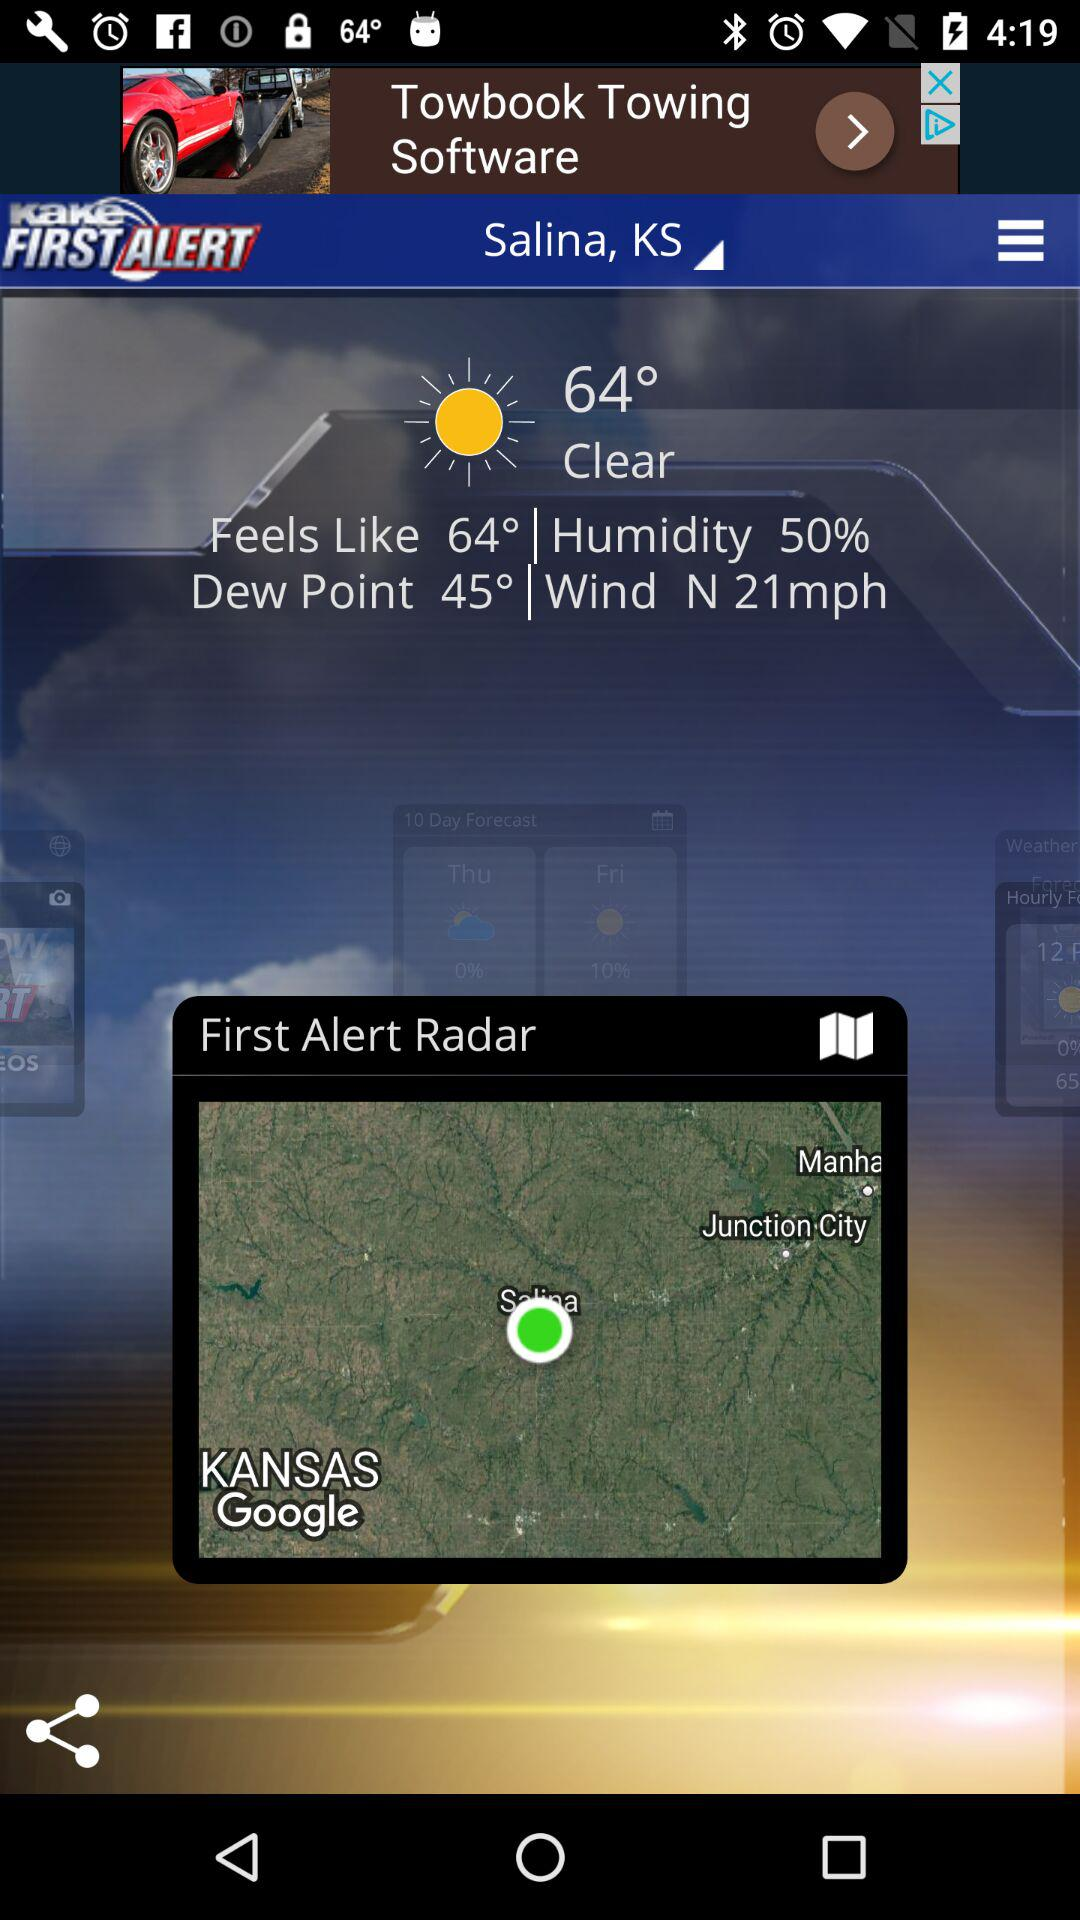How many degrees warmer is the current temperature than the dew point?
Answer the question using a single word or phrase. 19 